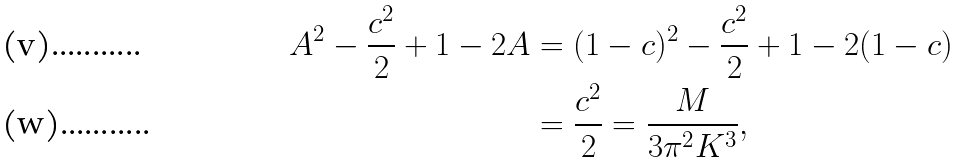Convert formula to latex. <formula><loc_0><loc_0><loc_500><loc_500>A ^ { 2 } - \frac { c ^ { 2 } } { 2 } + 1 - 2 A & = ( 1 - c ) ^ { 2 } - \frac { c ^ { 2 } } { 2 } + 1 - 2 ( 1 - c ) \\ & = \frac { c ^ { 2 } } { 2 } = \frac { M } { 3 \pi ^ { 2 } K ^ { 3 } } ,</formula> 